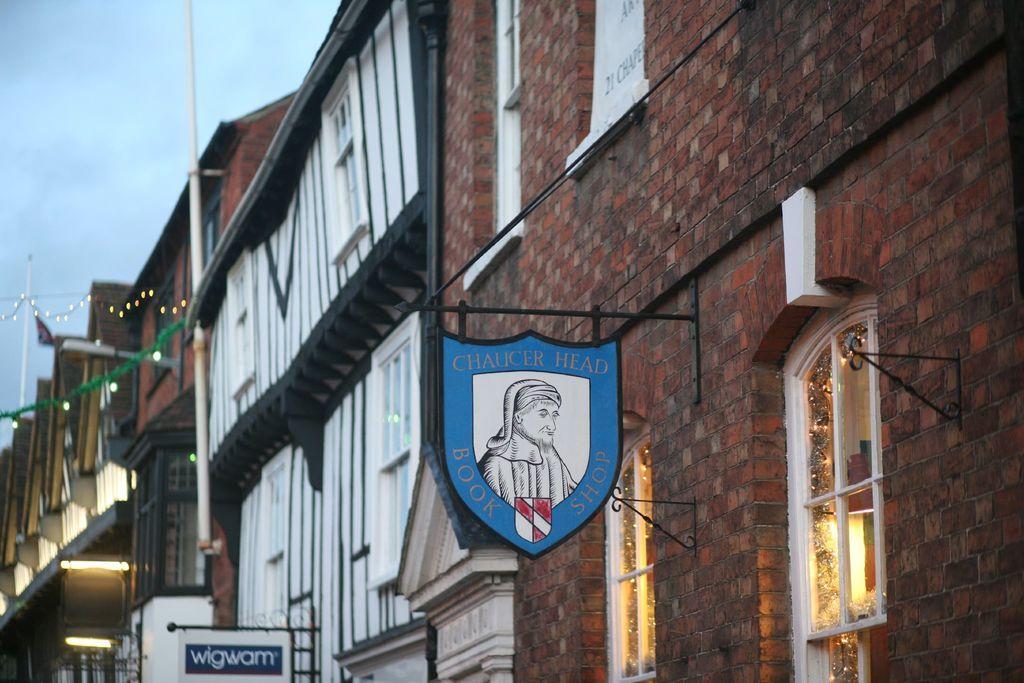Can you describe this image briefly? In this image there are buildings and on the wall of the buildings, there are boards with some text written on it and the sky is cloudy. 